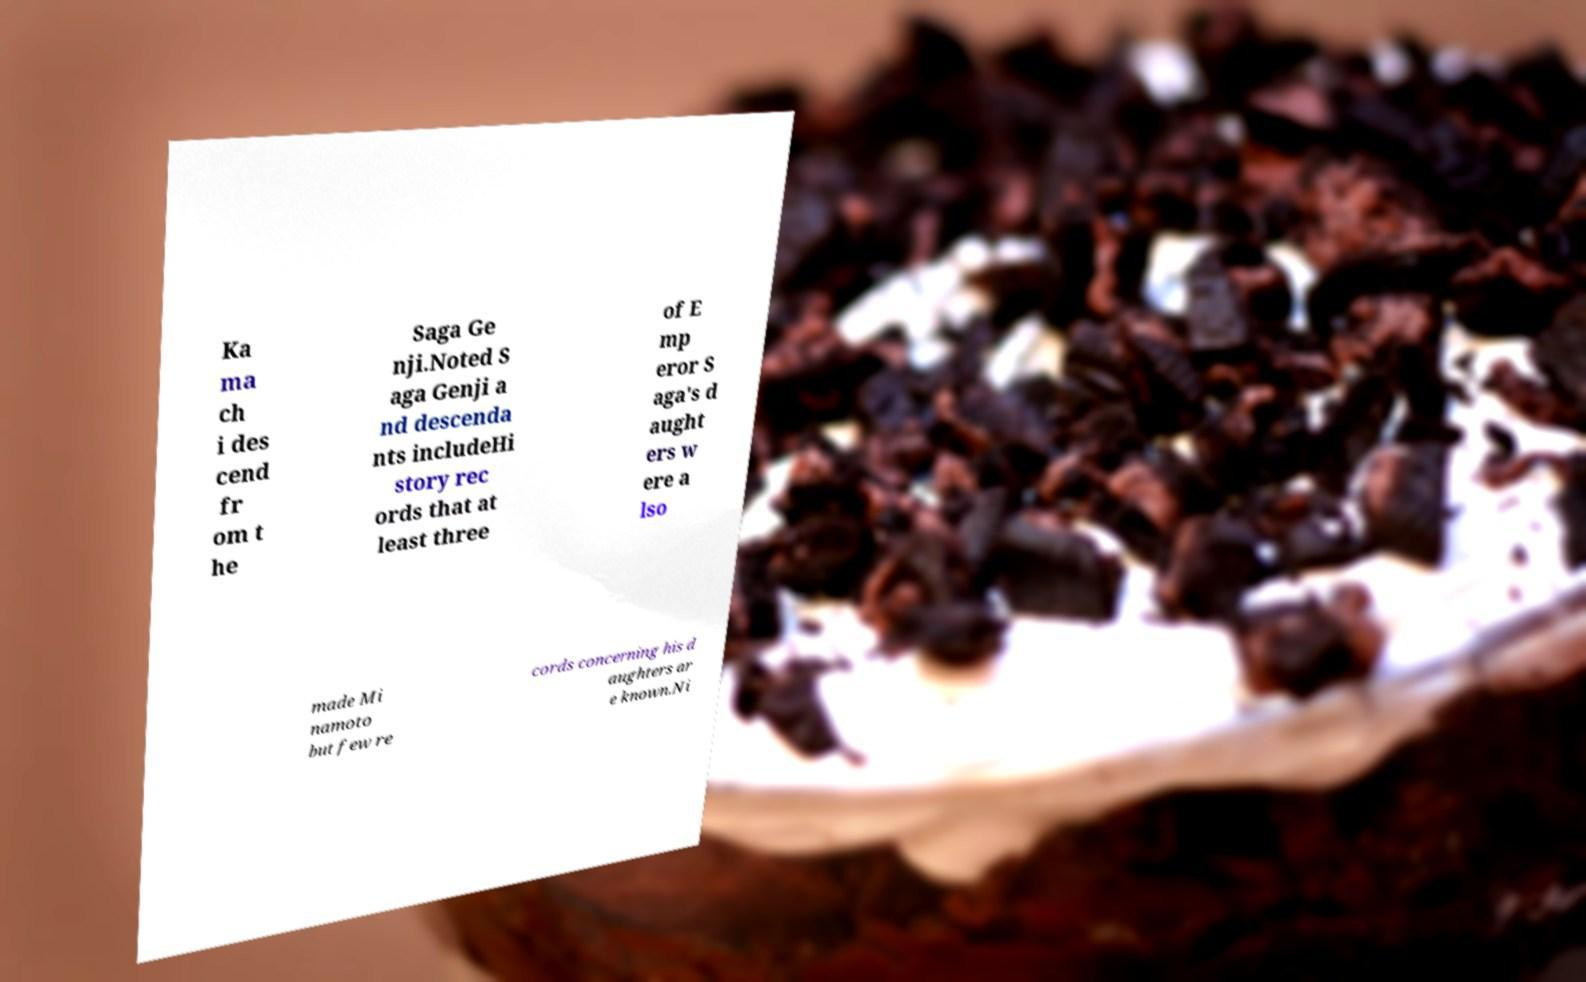I need the written content from this picture converted into text. Can you do that? Ka ma ch i des cend fr om t he Saga Ge nji.Noted S aga Genji a nd descenda nts includeHi story rec ords that at least three of E mp eror S aga's d aught ers w ere a lso made Mi namoto but few re cords concerning his d aughters ar e known.Ni 